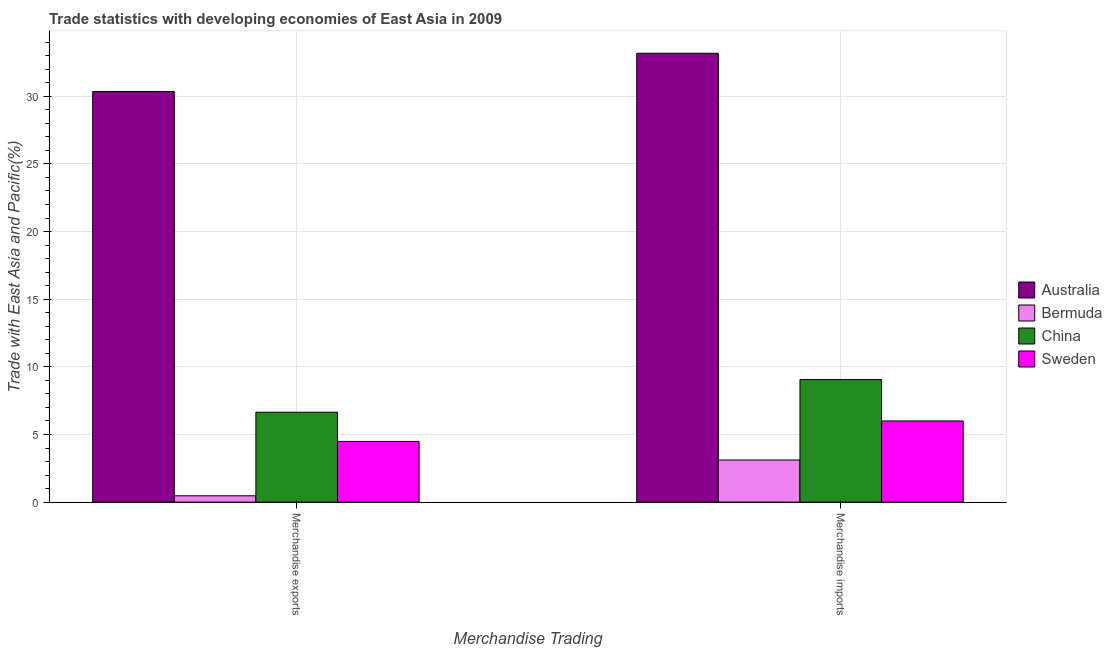How many bars are there on the 2nd tick from the left?
Keep it short and to the point. 4. How many bars are there on the 1st tick from the right?
Give a very brief answer. 4. What is the label of the 2nd group of bars from the left?
Keep it short and to the point. Merchandise imports. What is the merchandise exports in China?
Offer a terse response. 6.64. Across all countries, what is the maximum merchandise imports?
Make the answer very short. 33.18. Across all countries, what is the minimum merchandise exports?
Offer a very short reply. 0.47. In which country was the merchandise exports minimum?
Offer a terse response. Bermuda. What is the total merchandise exports in the graph?
Make the answer very short. 41.95. What is the difference between the merchandise imports in China and that in Sweden?
Make the answer very short. 3.06. What is the difference between the merchandise exports in Sweden and the merchandise imports in China?
Give a very brief answer. -4.57. What is the average merchandise exports per country?
Ensure brevity in your answer.  10.49. What is the difference between the merchandise imports and merchandise exports in China?
Offer a terse response. 2.41. What is the ratio of the merchandise imports in Australia to that in Bermuda?
Keep it short and to the point. 10.66. Is the merchandise imports in Australia less than that in China?
Provide a succinct answer. No. In how many countries, is the merchandise exports greater than the average merchandise exports taken over all countries?
Your response must be concise. 1. How many countries are there in the graph?
Ensure brevity in your answer.  4. What is the difference between two consecutive major ticks on the Y-axis?
Provide a succinct answer. 5. Are the values on the major ticks of Y-axis written in scientific E-notation?
Your response must be concise. No. Does the graph contain any zero values?
Make the answer very short. No. How many legend labels are there?
Your answer should be very brief. 4. How are the legend labels stacked?
Make the answer very short. Vertical. What is the title of the graph?
Your answer should be compact. Trade statistics with developing economies of East Asia in 2009. What is the label or title of the X-axis?
Offer a terse response. Merchandise Trading. What is the label or title of the Y-axis?
Your answer should be very brief. Trade with East Asia and Pacific(%). What is the Trade with East Asia and Pacific(%) in Australia in Merchandise exports?
Offer a terse response. 30.35. What is the Trade with East Asia and Pacific(%) in Bermuda in Merchandise exports?
Provide a short and direct response. 0.47. What is the Trade with East Asia and Pacific(%) in China in Merchandise exports?
Provide a succinct answer. 6.64. What is the Trade with East Asia and Pacific(%) in Sweden in Merchandise exports?
Your answer should be compact. 4.49. What is the Trade with East Asia and Pacific(%) in Australia in Merchandise imports?
Your response must be concise. 33.18. What is the Trade with East Asia and Pacific(%) in Bermuda in Merchandise imports?
Make the answer very short. 3.11. What is the Trade with East Asia and Pacific(%) of China in Merchandise imports?
Offer a very short reply. 9.06. What is the Trade with East Asia and Pacific(%) in Sweden in Merchandise imports?
Keep it short and to the point. 6. Across all Merchandise Trading, what is the maximum Trade with East Asia and Pacific(%) in Australia?
Offer a terse response. 33.18. Across all Merchandise Trading, what is the maximum Trade with East Asia and Pacific(%) in Bermuda?
Keep it short and to the point. 3.11. Across all Merchandise Trading, what is the maximum Trade with East Asia and Pacific(%) in China?
Provide a short and direct response. 9.06. Across all Merchandise Trading, what is the maximum Trade with East Asia and Pacific(%) of Sweden?
Your answer should be compact. 6. Across all Merchandise Trading, what is the minimum Trade with East Asia and Pacific(%) of Australia?
Keep it short and to the point. 30.35. Across all Merchandise Trading, what is the minimum Trade with East Asia and Pacific(%) in Bermuda?
Offer a very short reply. 0.47. Across all Merchandise Trading, what is the minimum Trade with East Asia and Pacific(%) in China?
Offer a very short reply. 6.64. Across all Merchandise Trading, what is the minimum Trade with East Asia and Pacific(%) in Sweden?
Your response must be concise. 4.49. What is the total Trade with East Asia and Pacific(%) of Australia in the graph?
Give a very brief answer. 63.53. What is the total Trade with East Asia and Pacific(%) of Bermuda in the graph?
Your answer should be very brief. 3.58. What is the total Trade with East Asia and Pacific(%) of China in the graph?
Give a very brief answer. 15.7. What is the total Trade with East Asia and Pacific(%) of Sweden in the graph?
Your answer should be very brief. 10.49. What is the difference between the Trade with East Asia and Pacific(%) in Australia in Merchandise exports and that in Merchandise imports?
Offer a terse response. -2.83. What is the difference between the Trade with East Asia and Pacific(%) in Bermuda in Merchandise exports and that in Merchandise imports?
Make the answer very short. -2.65. What is the difference between the Trade with East Asia and Pacific(%) of China in Merchandise exports and that in Merchandise imports?
Give a very brief answer. -2.41. What is the difference between the Trade with East Asia and Pacific(%) in Sweden in Merchandise exports and that in Merchandise imports?
Make the answer very short. -1.51. What is the difference between the Trade with East Asia and Pacific(%) of Australia in Merchandise exports and the Trade with East Asia and Pacific(%) of Bermuda in Merchandise imports?
Your answer should be compact. 27.24. What is the difference between the Trade with East Asia and Pacific(%) of Australia in Merchandise exports and the Trade with East Asia and Pacific(%) of China in Merchandise imports?
Provide a succinct answer. 21.29. What is the difference between the Trade with East Asia and Pacific(%) in Australia in Merchandise exports and the Trade with East Asia and Pacific(%) in Sweden in Merchandise imports?
Make the answer very short. 24.35. What is the difference between the Trade with East Asia and Pacific(%) in Bermuda in Merchandise exports and the Trade with East Asia and Pacific(%) in China in Merchandise imports?
Provide a succinct answer. -8.59. What is the difference between the Trade with East Asia and Pacific(%) in Bermuda in Merchandise exports and the Trade with East Asia and Pacific(%) in Sweden in Merchandise imports?
Offer a terse response. -5.53. What is the difference between the Trade with East Asia and Pacific(%) of China in Merchandise exports and the Trade with East Asia and Pacific(%) of Sweden in Merchandise imports?
Ensure brevity in your answer.  0.64. What is the average Trade with East Asia and Pacific(%) of Australia per Merchandise Trading?
Give a very brief answer. 31.77. What is the average Trade with East Asia and Pacific(%) of Bermuda per Merchandise Trading?
Your answer should be compact. 1.79. What is the average Trade with East Asia and Pacific(%) in China per Merchandise Trading?
Make the answer very short. 7.85. What is the average Trade with East Asia and Pacific(%) of Sweden per Merchandise Trading?
Your response must be concise. 5.24. What is the difference between the Trade with East Asia and Pacific(%) in Australia and Trade with East Asia and Pacific(%) in Bermuda in Merchandise exports?
Your answer should be compact. 29.88. What is the difference between the Trade with East Asia and Pacific(%) in Australia and Trade with East Asia and Pacific(%) in China in Merchandise exports?
Ensure brevity in your answer.  23.71. What is the difference between the Trade with East Asia and Pacific(%) in Australia and Trade with East Asia and Pacific(%) in Sweden in Merchandise exports?
Give a very brief answer. 25.87. What is the difference between the Trade with East Asia and Pacific(%) of Bermuda and Trade with East Asia and Pacific(%) of China in Merchandise exports?
Offer a terse response. -6.18. What is the difference between the Trade with East Asia and Pacific(%) in Bermuda and Trade with East Asia and Pacific(%) in Sweden in Merchandise exports?
Your response must be concise. -4.02. What is the difference between the Trade with East Asia and Pacific(%) of China and Trade with East Asia and Pacific(%) of Sweden in Merchandise exports?
Your answer should be compact. 2.16. What is the difference between the Trade with East Asia and Pacific(%) of Australia and Trade with East Asia and Pacific(%) of Bermuda in Merchandise imports?
Your response must be concise. 30.07. What is the difference between the Trade with East Asia and Pacific(%) of Australia and Trade with East Asia and Pacific(%) of China in Merchandise imports?
Your answer should be compact. 24.12. What is the difference between the Trade with East Asia and Pacific(%) in Australia and Trade with East Asia and Pacific(%) in Sweden in Merchandise imports?
Provide a succinct answer. 27.18. What is the difference between the Trade with East Asia and Pacific(%) of Bermuda and Trade with East Asia and Pacific(%) of China in Merchandise imports?
Offer a terse response. -5.94. What is the difference between the Trade with East Asia and Pacific(%) in Bermuda and Trade with East Asia and Pacific(%) in Sweden in Merchandise imports?
Offer a very short reply. -2.89. What is the difference between the Trade with East Asia and Pacific(%) of China and Trade with East Asia and Pacific(%) of Sweden in Merchandise imports?
Provide a succinct answer. 3.06. What is the ratio of the Trade with East Asia and Pacific(%) in Australia in Merchandise exports to that in Merchandise imports?
Provide a succinct answer. 0.91. What is the ratio of the Trade with East Asia and Pacific(%) of Bermuda in Merchandise exports to that in Merchandise imports?
Your answer should be very brief. 0.15. What is the ratio of the Trade with East Asia and Pacific(%) in China in Merchandise exports to that in Merchandise imports?
Your response must be concise. 0.73. What is the ratio of the Trade with East Asia and Pacific(%) of Sweden in Merchandise exports to that in Merchandise imports?
Your response must be concise. 0.75. What is the difference between the highest and the second highest Trade with East Asia and Pacific(%) of Australia?
Make the answer very short. 2.83. What is the difference between the highest and the second highest Trade with East Asia and Pacific(%) in Bermuda?
Offer a very short reply. 2.65. What is the difference between the highest and the second highest Trade with East Asia and Pacific(%) in China?
Keep it short and to the point. 2.41. What is the difference between the highest and the second highest Trade with East Asia and Pacific(%) of Sweden?
Offer a very short reply. 1.51. What is the difference between the highest and the lowest Trade with East Asia and Pacific(%) in Australia?
Offer a very short reply. 2.83. What is the difference between the highest and the lowest Trade with East Asia and Pacific(%) of Bermuda?
Offer a very short reply. 2.65. What is the difference between the highest and the lowest Trade with East Asia and Pacific(%) in China?
Make the answer very short. 2.41. What is the difference between the highest and the lowest Trade with East Asia and Pacific(%) in Sweden?
Make the answer very short. 1.51. 